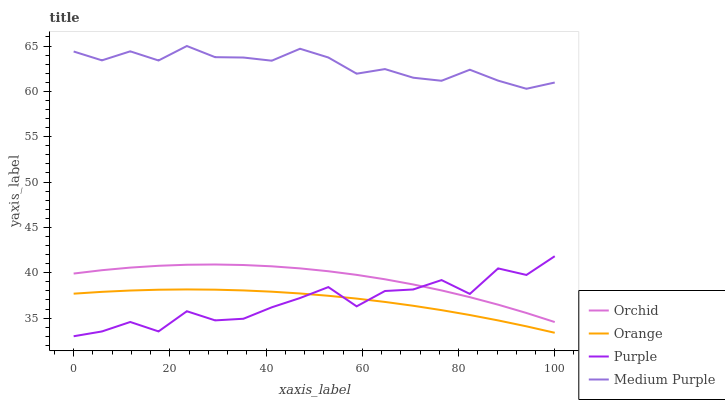Does Purple have the minimum area under the curve?
Answer yes or no. Yes. Does Medium Purple have the maximum area under the curve?
Answer yes or no. Yes. Does Medium Purple have the minimum area under the curve?
Answer yes or no. No. Does Purple have the maximum area under the curve?
Answer yes or no. No. Is Orange the smoothest?
Answer yes or no. Yes. Is Purple the roughest?
Answer yes or no. Yes. Is Medium Purple the smoothest?
Answer yes or no. No. Is Medium Purple the roughest?
Answer yes or no. No. Does Medium Purple have the lowest value?
Answer yes or no. No. Does Purple have the highest value?
Answer yes or no. No. Is Orchid less than Medium Purple?
Answer yes or no. Yes. Is Orchid greater than Orange?
Answer yes or no. Yes. Does Orchid intersect Medium Purple?
Answer yes or no. No. 